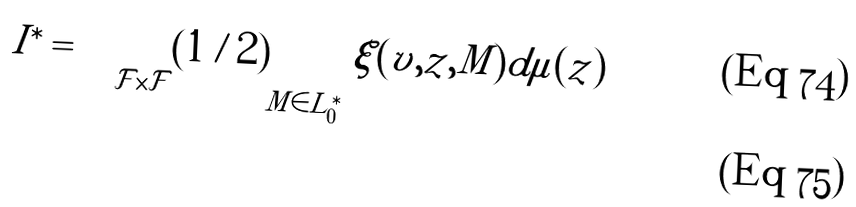<formula> <loc_0><loc_0><loc_500><loc_500>I ^ { \ast } = & \int _ { \mathcal { F } \times \mathcal { F } } ( 1 / 2 ) \sum _ { M \in L ^ { \ast } _ { 0 } } \xi ( v , z , M ) d \mu ( z ) \\</formula> 